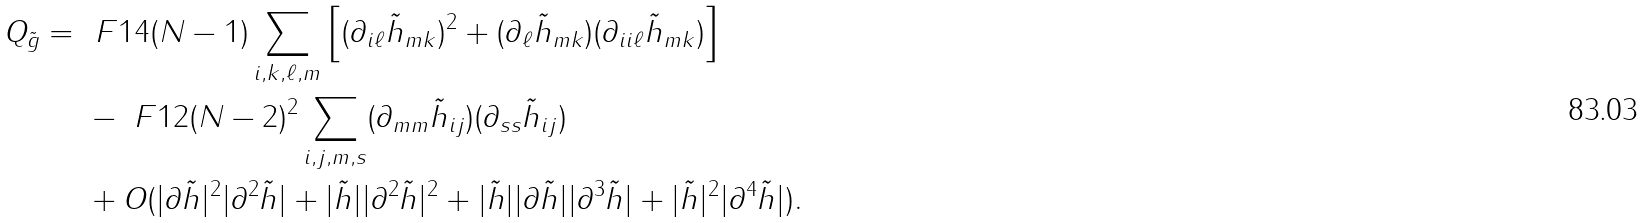Convert formula to latex. <formula><loc_0><loc_0><loc_500><loc_500>Q _ { \tilde { g } } = & \ \ F { 1 } { 4 ( N - 1 ) } \sum _ { i , k , \ell , m } \left [ ( \partial _ { i \ell } \tilde { h } _ { m k } ) ^ { 2 } + ( \partial _ { \ell } \tilde { h } _ { m k } ) ( \partial _ { i i \ell } \tilde { h } _ { m k } ) \right ] \\ & \ - \ F { 1 } { 2 ( N - 2 ) ^ { 2 } } \sum _ { i , j , m , s } ( \partial _ { m m } \tilde { h } _ { i j } ) ( \partial _ { s s } \tilde { h } _ { i j } ) \\ & \ + O ( | \partial \tilde { h } | ^ { 2 } | \partial ^ { 2 } \tilde { h } | + | \tilde { h } | | \partial ^ { 2 } \tilde { h } | ^ { 2 } + | \tilde { h } | | \partial \tilde { h } | | \partial ^ { 3 } \tilde { h } | + | \tilde { h } | ^ { 2 } | \partial ^ { 4 } \tilde { h } | ) .</formula> 